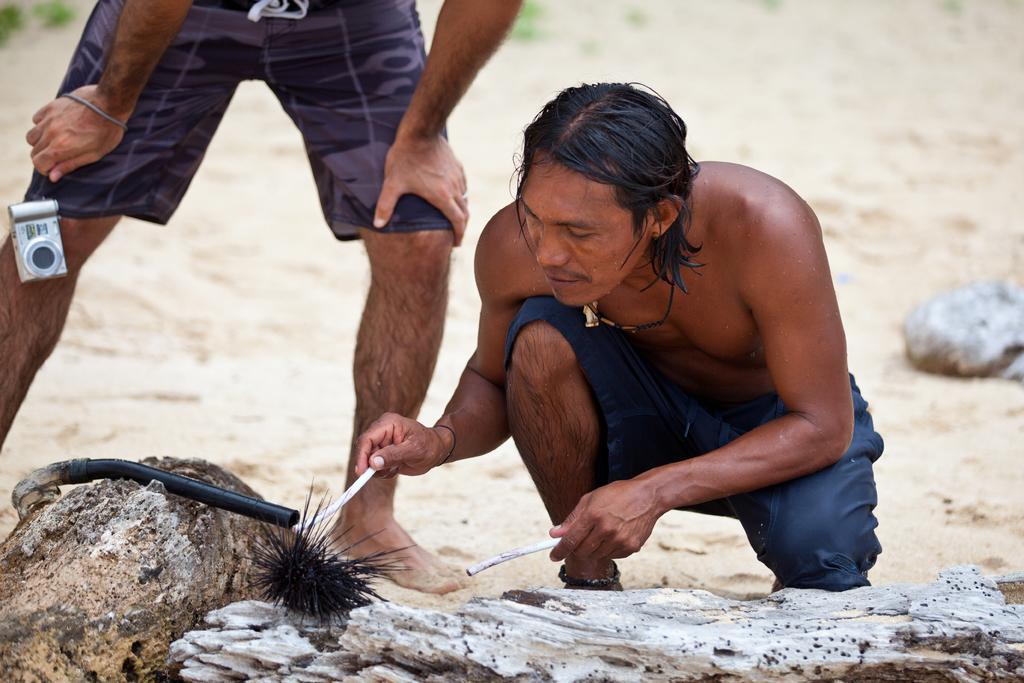Describe this image in one or two sentences. In this image I can see a person wearing blue colored shirt is sitting and holding two white colored objects in his hands. I can see another person wearing shirt is standing and holding a camera in his hands. I can see a black colored urchin on the ground, a black colored object and a rock which is white in color. In the background I can see the ground and some grass which is green in color. 